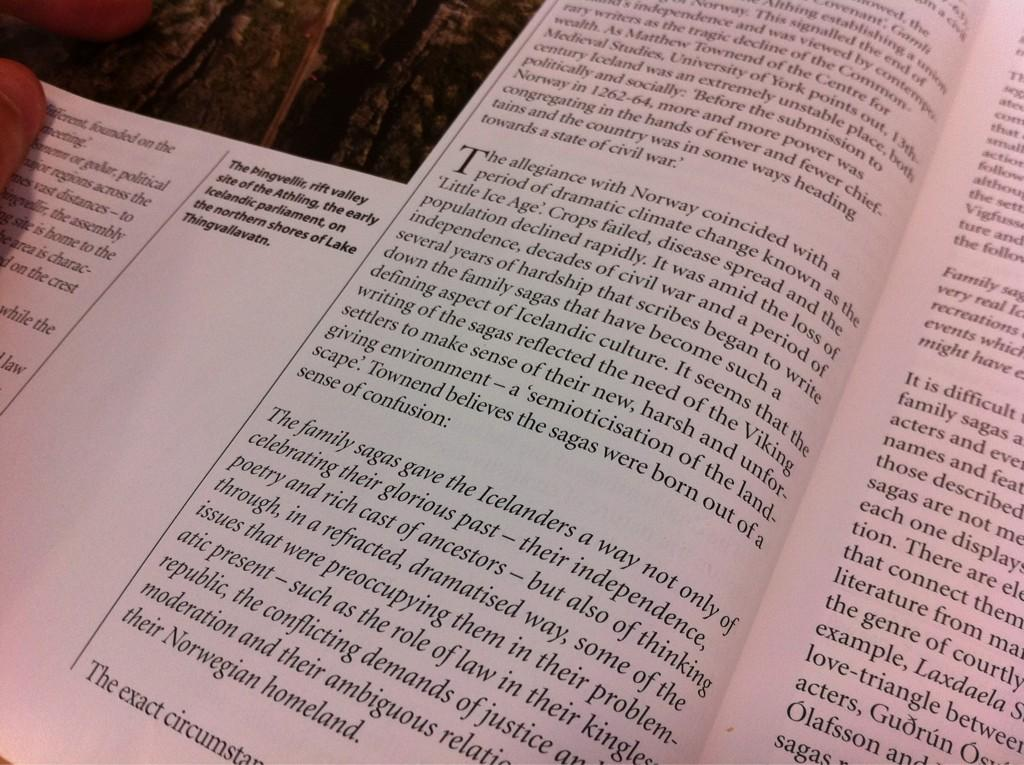Provide a one-sentence caption for the provided image. A book that is open and shows information mentioning icelanders on the pages. 